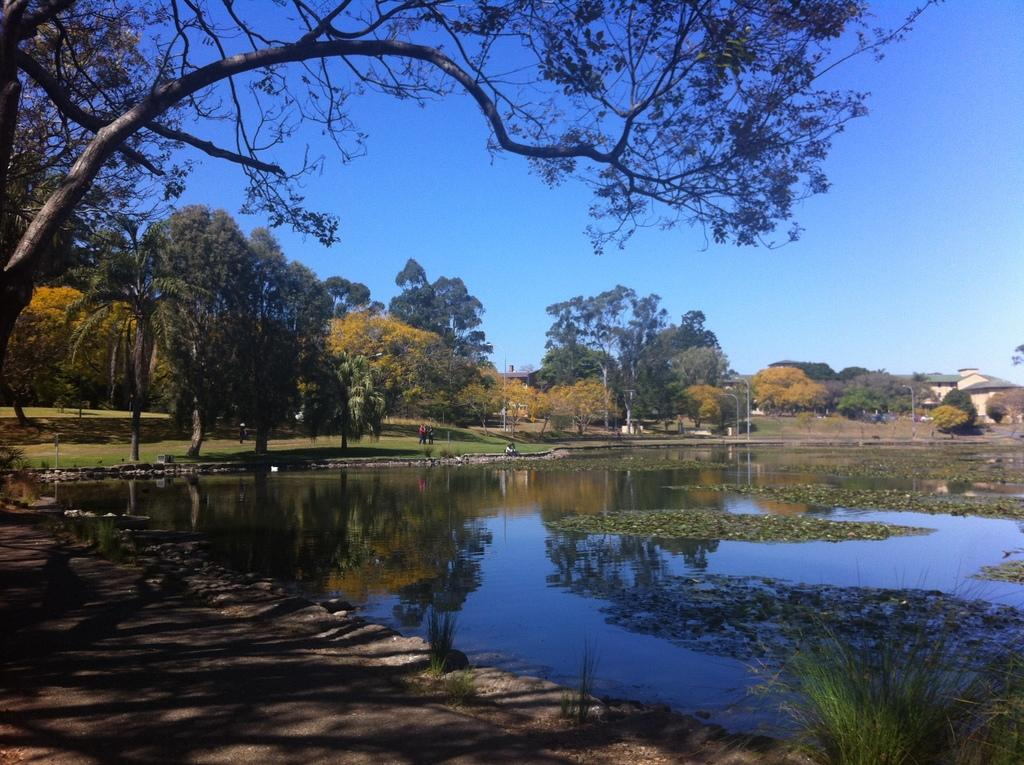What type of vegetation can be seen in the image? There are trees and plants in the image. What natural element is visible in the image? There is water visible in the image. What type of ground cover is present in the image? There is grass in the image. What man-made structures can be seen in the image? There are poles in the image. What is visible in the background of the image? The sky is visible in the background of the image. What type of box can be seen in the image? There is no box present in the image. What type of canvas is visible in the image? There is no canvas present in the image. 